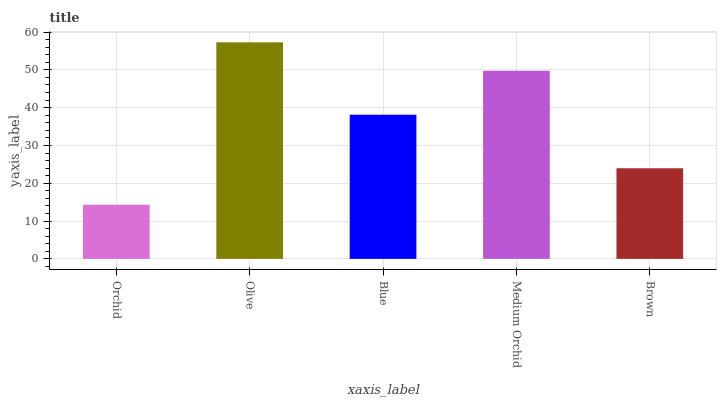Is Orchid the minimum?
Answer yes or no. Yes. Is Olive the maximum?
Answer yes or no. Yes. Is Blue the minimum?
Answer yes or no. No. Is Blue the maximum?
Answer yes or no. No. Is Olive greater than Blue?
Answer yes or no. Yes. Is Blue less than Olive?
Answer yes or no. Yes. Is Blue greater than Olive?
Answer yes or no. No. Is Olive less than Blue?
Answer yes or no. No. Is Blue the high median?
Answer yes or no. Yes. Is Blue the low median?
Answer yes or no. Yes. Is Medium Orchid the high median?
Answer yes or no. No. Is Medium Orchid the low median?
Answer yes or no. No. 